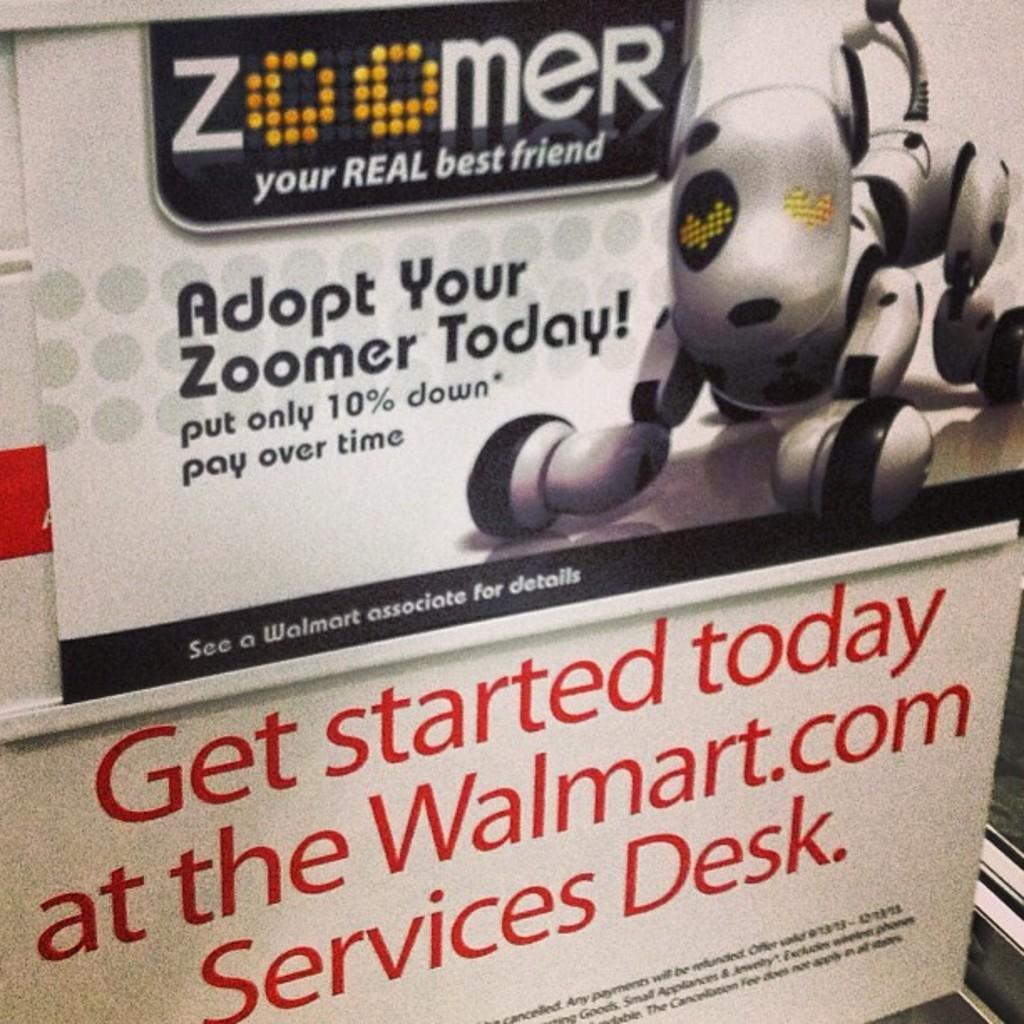<image>
Give a short and clear explanation of the subsequent image. A poster advertising a Zoomer, your real best friend robot dog is above a sign for Walmart.com. 